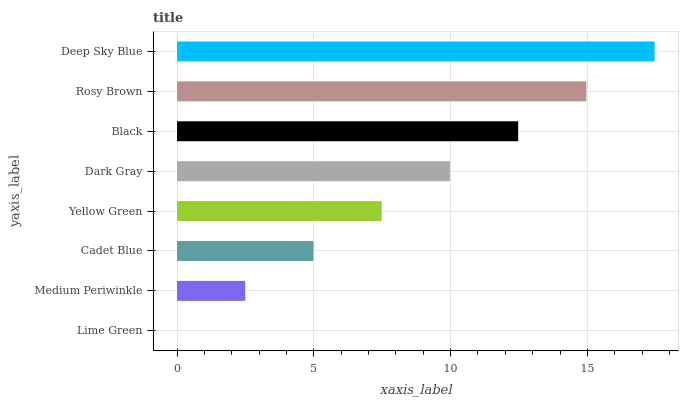Is Lime Green the minimum?
Answer yes or no. Yes. Is Deep Sky Blue the maximum?
Answer yes or no. Yes. Is Medium Periwinkle the minimum?
Answer yes or no. No. Is Medium Periwinkle the maximum?
Answer yes or no. No. Is Medium Periwinkle greater than Lime Green?
Answer yes or no. Yes. Is Lime Green less than Medium Periwinkle?
Answer yes or no. Yes. Is Lime Green greater than Medium Periwinkle?
Answer yes or no. No. Is Medium Periwinkle less than Lime Green?
Answer yes or no. No. Is Dark Gray the high median?
Answer yes or no. Yes. Is Yellow Green the low median?
Answer yes or no. Yes. Is Rosy Brown the high median?
Answer yes or no. No. Is Black the low median?
Answer yes or no. No. 